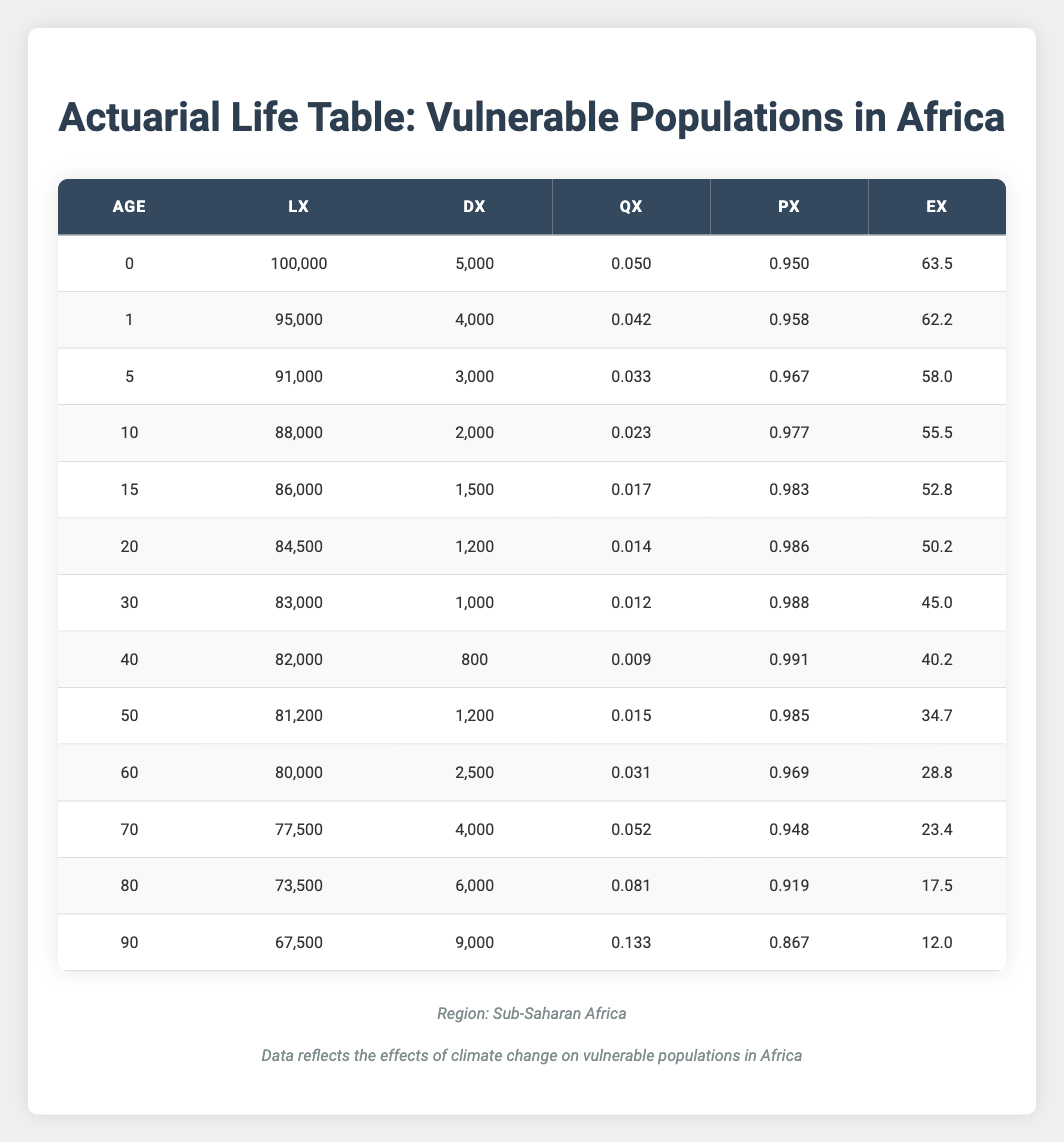What is the probability of dying before reaching age 1 in vulnerable populations in Africa? The probability of dying before age 1 is represented by "q0" from the table, which is 0.050.
Answer: 0.050 What is the life expectancy at age 60 for vulnerable populations in Africa? The life expectancy at age 60 is indicated by "e60" in the table, which is 28.8 years.
Answer: 28.8 How many individuals are expected to survive to age 70 starting from age 0? Starting with 100,000 individuals at age 0, we look up the value of lx at age 70, which is 77,500. This means 77,500 individuals are expected to survive to age 70.
Answer: 77,500 Is the probability of dying between ages 10 and 15 higher than between ages 15 and 20? We compare q10 (0.023) and q15 (0.017) and find that q10 is greater than q15. Thus, the probability of dying between ages 10 and 15 is higher.
Answer: Yes What is the difference in life expectancy between ages 70 and 80? The life expectancy at age 70 is 23.4 years and at age 80 is 17.5 years. The difference is 23.4 - 17.5 = 5.9 years.
Answer: 5.9 At what age does the probability of dying (qx) increase to over 0.05? Looking at the values of qx in the table, it first exceeds 0.05 at age 70, where q70 is 0.052.
Answer: Age 70 What is the total number of individuals who are expected to die before age 50, starting from age 0? We calculate the total deaths by adding dx values from ages 0 to 49: 5000 + 4000 + 3000 + 2000 + 1500 + 1200 + 1000 + 800 + 1200 = 18,700.
Answer: 18,700 Is the probability of surviving from age 60 to 70 greater than from age 70 to 80? We compare p60 (0.969) and p70 (0.948). Since 0.969 > 0.948, the probability of surviving from age 60 to 70 is greater.
Answer: Yes What is the average life expectancy for individuals aged 50 and above? The life expectancies for ages 50, 60, 70, 80, and 90 are 34.7, 28.8, 23.4, 17.5, and 12.0, respectively. The average is (34.7 + 28.8 + 23.4 + 17.5 + 12.0) / 5 = 23.52 years.
Answer: 23.52 